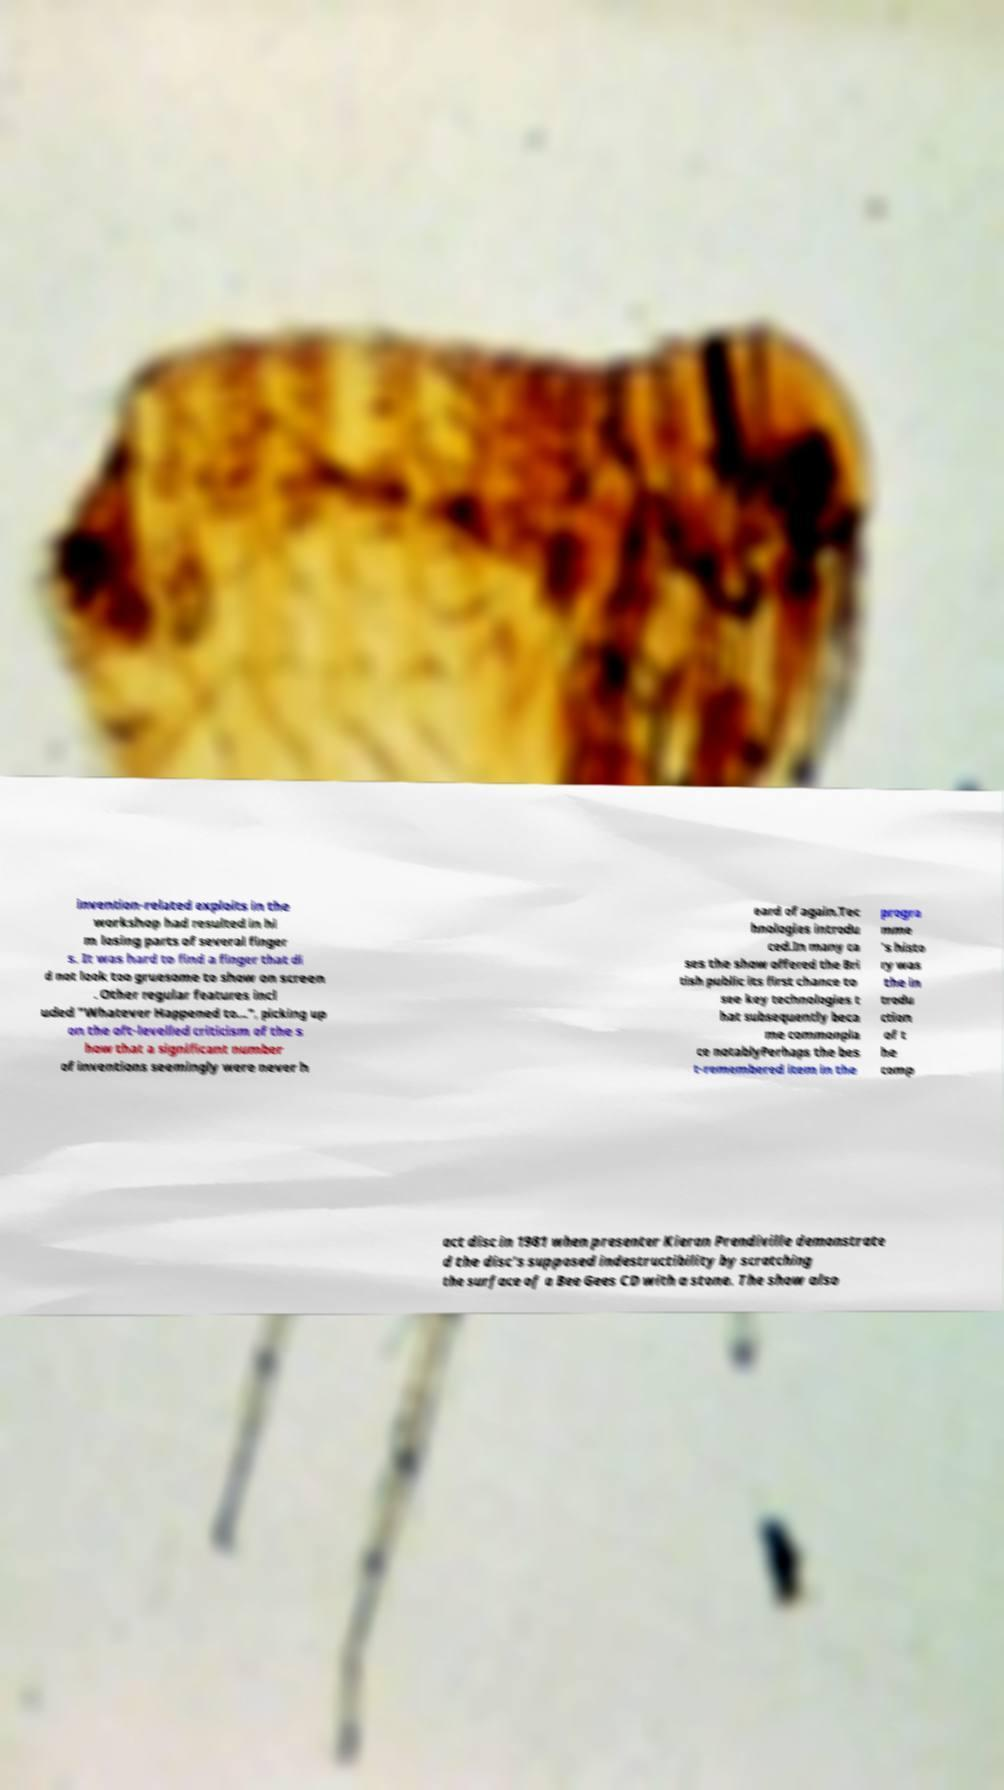Please read and relay the text visible in this image. What does it say? invention-related exploits in the workshop had resulted in hi m losing parts of several finger s. It was hard to find a finger that di d not look too gruesome to show on screen . Other regular features incl uded "Whatever Happened to...", picking up on the oft-levelled criticism of the s how that a significant number of inventions seemingly were never h eard of again.Tec hnologies introdu ced.In many ca ses the show offered the Bri tish public its first chance to see key technologies t hat subsequently beca me commonpla ce notablyPerhaps the bes t-remembered item in the progra mme 's histo ry was the in trodu ction of t he comp act disc in 1981 when presenter Kieran Prendiville demonstrate d the disc's supposed indestructibility by scratching the surface of a Bee Gees CD with a stone. The show also 